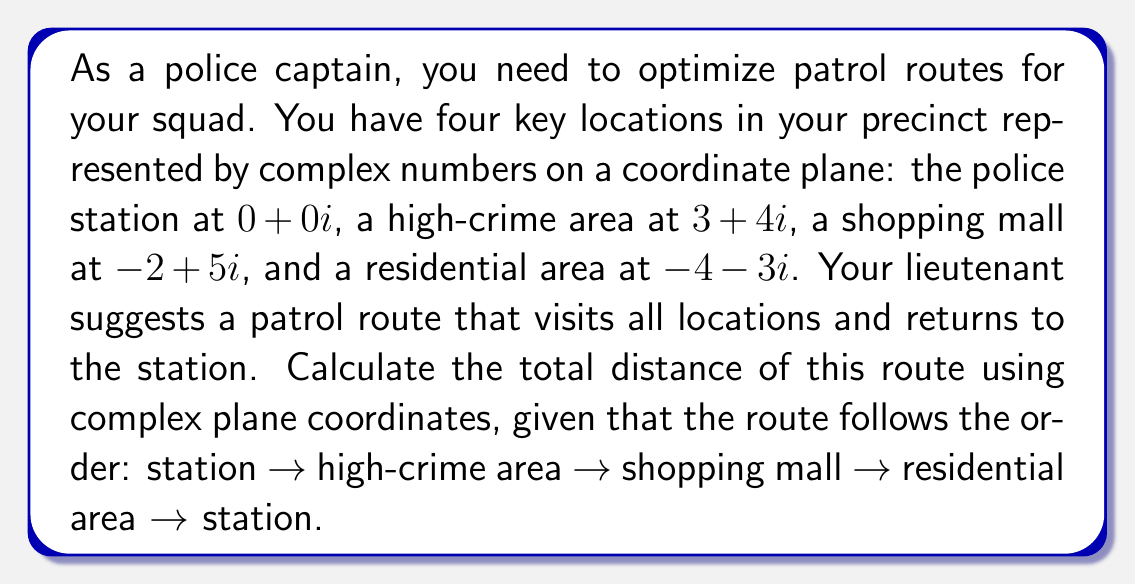What is the answer to this math problem? To solve this problem, we need to follow these steps:

1) Identify the complex numbers representing each location:
   - Station: $z_1 = 0+0i$
   - High-crime area: $z_2 = 3+4i$
   - Shopping mall: $z_3 = -2+5i$
   - Residential area: $z_4 = -4-3i$

2) Calculate the distance between each pair of consecutive points using the absolute value of the difference between complex numbers:

   $d_{12} = |z_2 - z_1| = |(3+4i) - (0+0i)| = |3+4i| = \sqrt{3^2 + 4^2} = 5$

   $d_{23} = |z_3 - z_2| = |(-2+5i) - (3+4i)| = |-5+i| = \sqrt{(-5)^2 + 1^2} = \sqrt{26}$

   $d_{34} = |z_4 - z_3| = |(-4-3i) - (-2+5i)| = |-2-8i| = \sqrt{(-2)^2 + (-8)^2} = \sqrt{68}$

   $d_{41} = |z_1 - z_4| = |(0+0i) - (-4-3i)| = |4+3i| = \sqrt{4^2 + 3^2} = 5$

3) Sum up all the distances to get the total route length:

   Total distance = $d_{12} + d_{23} + d_{34} + d_{41}$
                  $= 5 + \sqrt{26} + \sqrt{68} + 5$
                  $= 10 + \sqrt{26} + \sqrt{68}$
Answer: The total distance of the patrol route is $10 + \sqrt{26} + \sqrt{68}$ units. 